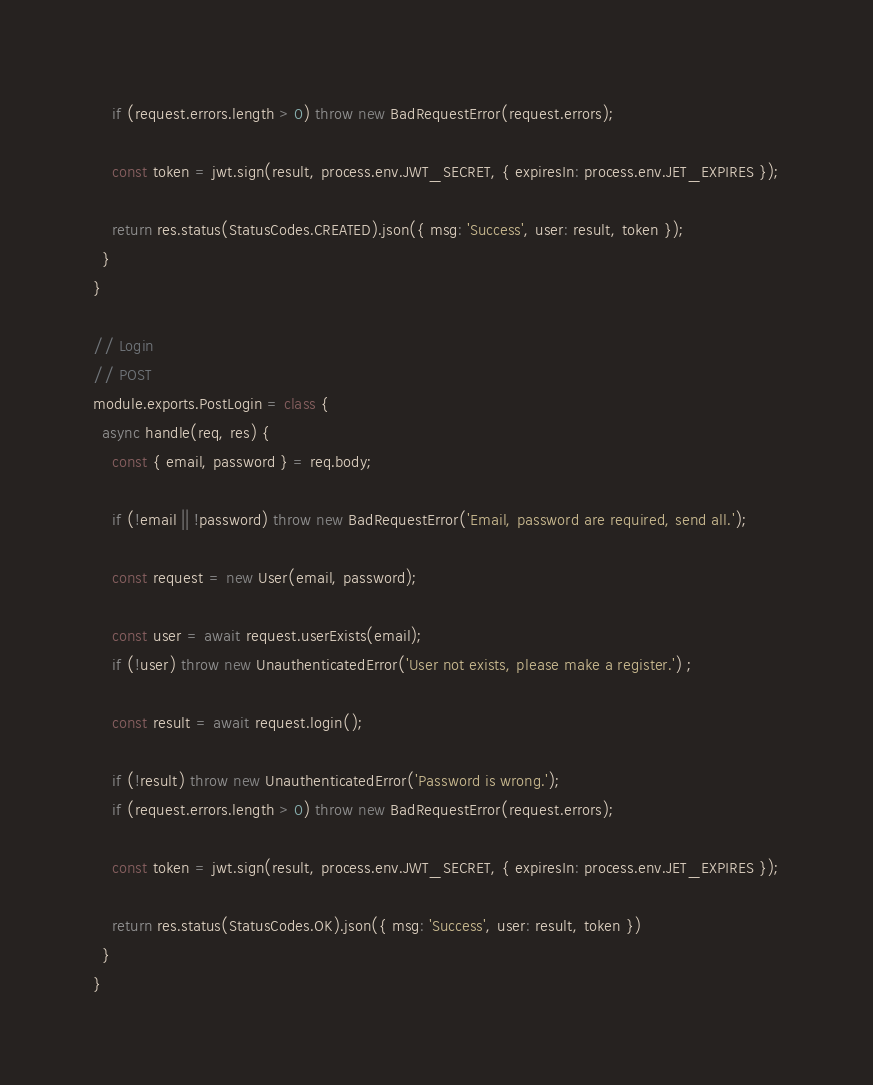Convert code to text. <code><loc_0><loc_0><loc_500><loc_500><_JavaScript_>
    if (request.errors.length > 0) throw new BadRequestError(request.errors);

    const token = jwt.sign(result, process.env.JWT_SECRET, { expiresIn: process.env.JET_EXPIRES });

    return res.status(StatusCodes.CREATED).json({ msg: 'Success', user: result, token });
  }
}

// Login
// POST
module.exports.PostLogin = class {
  async handle(req, res) {
    const { email, password } = req.body;

    if (!email || !password) throw new BadRequestError('Email, password are required, send all.');

    const request = new User(email, password);

    const user = await request.userExists(email);
    if (!user) throw new UnauthenticatedError('User not exists, please make a register.') ;

    const result = await request.login();

    if (!result) throw new UnauthenticatedError('Password is wrong.');
    if (request.errors.length > 0) throw new BadRequestError(request.errors);

    const token = jwt.sign(result, process.env.JWT_SECRET, { expiresIn: process.env.JET_EXPIRES });

    return res.status(StatusCodes.OK).json({ msg: 'Success', user: result, token })
  }
}
</code> 